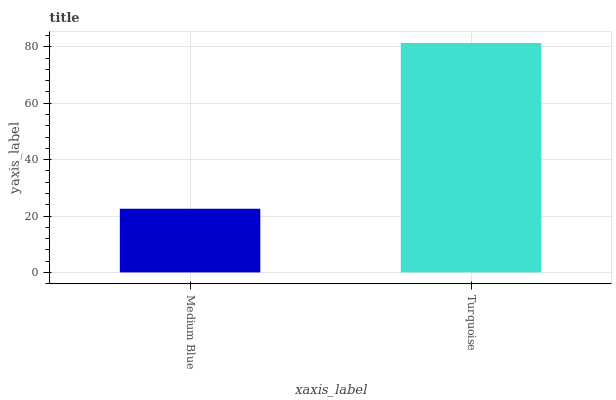Is Medium Blue the minimum?
Answer yes or no. Yes. Is Turquoise the maximum?
Answer yes or no. Yes. Is Turquoise the minimum?
Answer yes or no. No. Is Turquoise greater than Medium Blue?
Answer yes or no. Yes. Is Medium Blue less than Turquoise?
Answer yes or no. Yes. Is Medium Blue greater than Turquoise?
Answer yes or no. No. Is Turquoise less than Medium Blue?
Answer yes or no. No. Is Turquoise the high median?
Answer yes or no. Yes. Is Medium Blue the low median?
Answer yes or no. Yes. Is Medium Blue the high median?
Answer yes or no. No. Is Turquoise the low median?
Answer yes or no. No. 